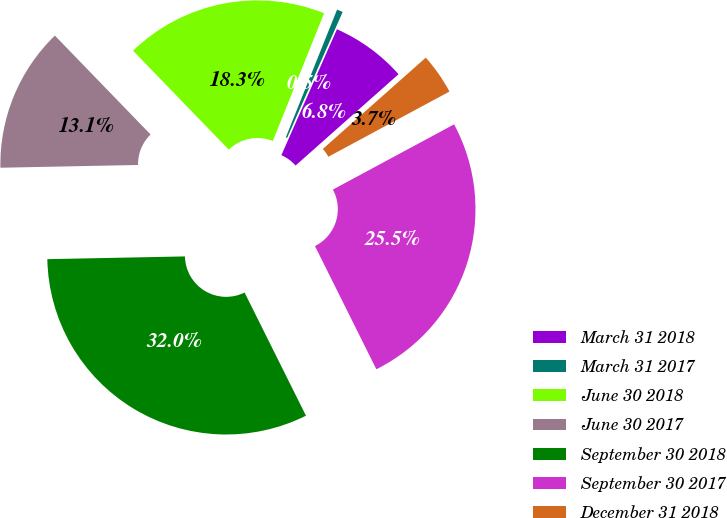<chart> <loc_0><loc_0><loc_500><loc_500><pie_chart><fcel>March 31 2018<fcel>March 31 2017<fcel>June 30 2018<fcel>June 30 2017<fcel>September 30 2018<fcel>September 30 2017<fcel>December 31 2018<nl><fcel>6.84%<fcel>0.54%<fcel>18.31%<fcel>13.08%<fcel>32.04%<fcel>25.5%<fcel>3.69%<nl></chart> 